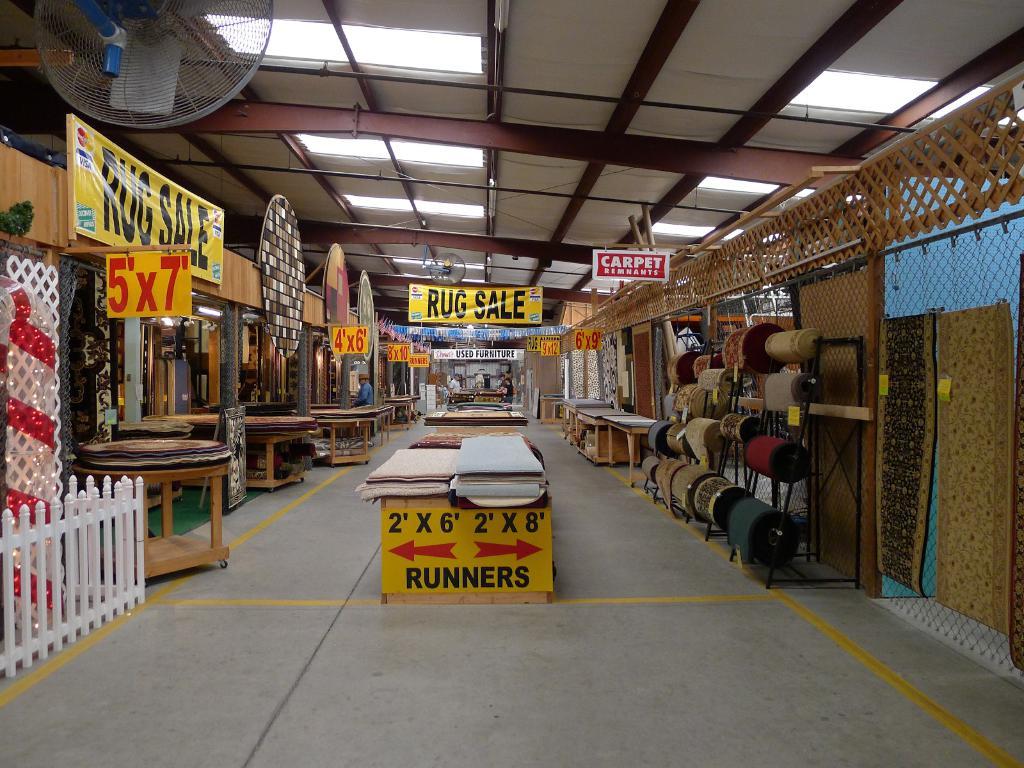What is "2'x6'"?
Your answer should be very brief. Runners. What kind of sale?
Your response must be concise. Rug. 